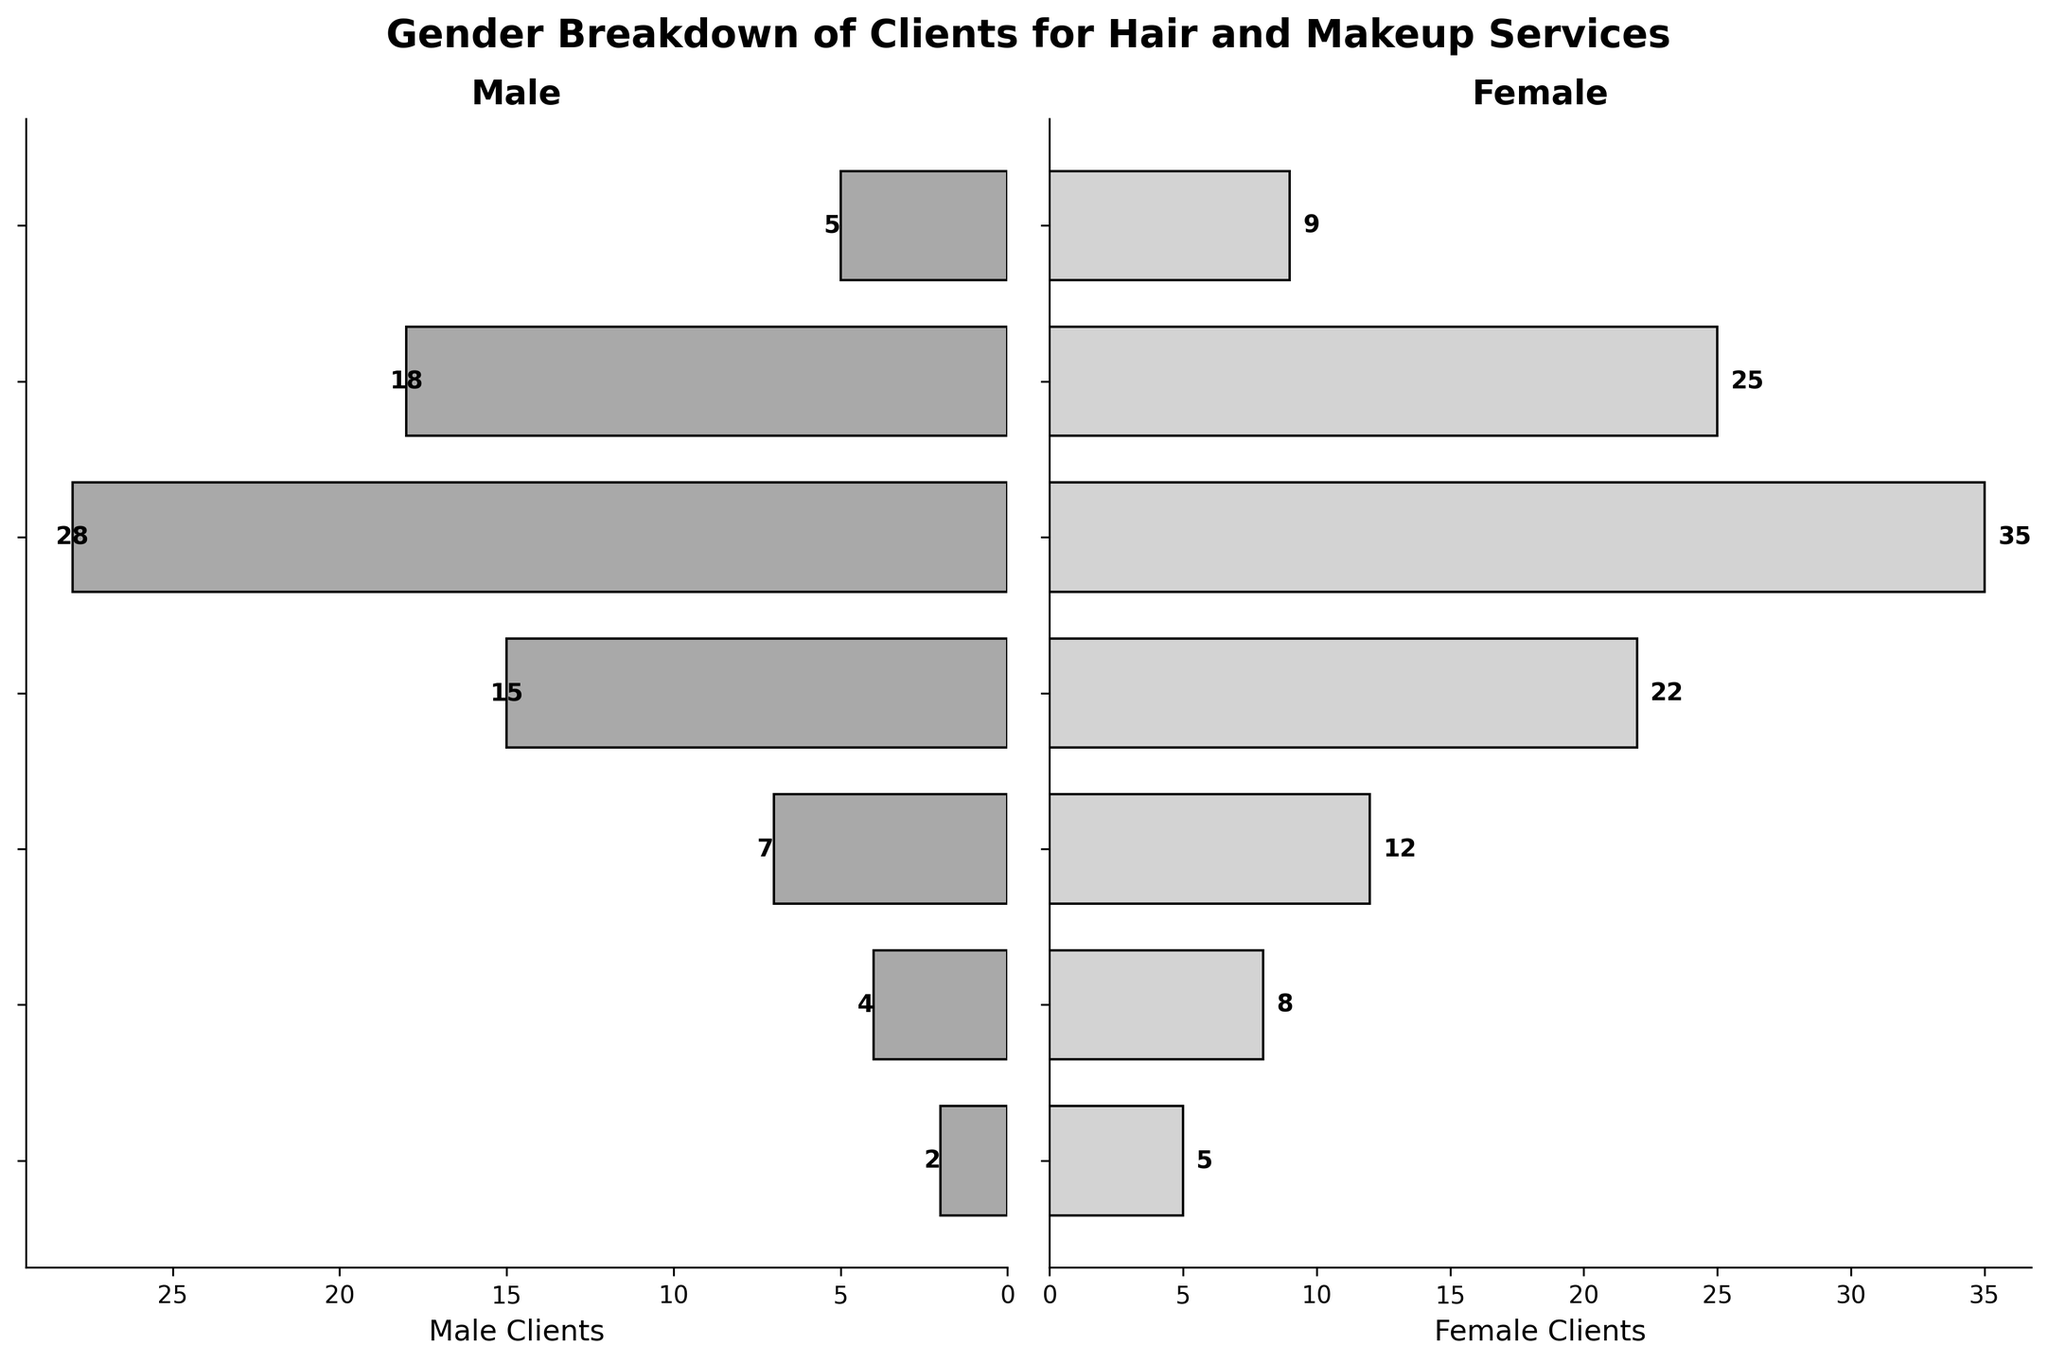What's the title of the figure? The title of the figure is written at the top in bold. It reads "Gender Breakdown of Clients for Hair and Makeup Services".
Answer: Gender Breakdown of Clients for Hair and Makeup Services How many age groups are displayed in the figure? Look at the labels on the y-axis of either side of the subplot. There are 7 age groups listed.
Answer: 7 Which age group has the highest number of male clients? According to the length of the bars in the male section (left-side plot), the "25-34" age group has the longest bar. This indicates the highest number of male clients.
Answer: 25-34 How many female clients are there in the "45-54" age group? Look at the bar corresponding to the "45-54" age group in the female section (right-side plot). The bar's length represents the number of clients, and the value placed next to the bar is 12.
Answer: 12 What is the total number of clients (both male and female) in the "18-24" age group? Sum the number of male and female clients in the "18-24" age group. The male clients are 18 and female clients are 25. So, the total number of clients is 18 + 25.
Answer: 43 Which age group shows a higher female client count compared to male client count? Check each age group to see where the female bar is longer than the male bar. This is true for every age group as female client counts are higher than male client counts in all age groups.
Answer: All age groups Among the age groups provided, which has the fewest male clients? According to the plot on the left side, the "65+" age group has the shortest bar, which corresponds to 2 male clients.
Answer: 65+ What is the difference between male and female clients in the "35-44" age group? Find the values for both genders in the "35-44" age group. The male clients are 15 and the female clients are 22. The difference is calculated as 22 - 15.
Answer: 7 How many more female clients are there than male clients in the "55-64" age group? Look at the bars for the "55-64" age group. The female clients are 8, and the male clients are 4. The difference is 8 - 4.
Answer: 4 What is the total number of clients across all age groups? Add the total number of male clients (2 + 4 + 7 + 15 + 28 + 18 + 5) and female clients (5 + 8 + 12 + 22 + 35 + 25 + 9). The sum of male clients is 79, and the sum of female clients is 116. So, the total number of clients is 79 + 116.
Answer: 195 